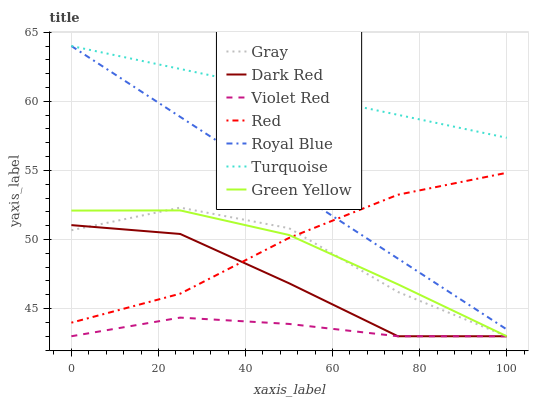Does Violet Red have the minimum area under the curve?
Answer yes or no. Yes. Does Turquoise have the maximum area under the curve?
Answer yes or no. Yes. Does Dark Red have the minimum area under the curve?
Answer yes or no. No. Does Dark Red have the maximum area under the curve?
Answer yes or no. No. Is Turquoise the smoothest?
Answer yes or no. Yes. Is Gray the roughest?
Answer yes or no. Yes. Is Violet Red the smoothest?
Answer yes or no. No. Is Violet Red the roughest?
Answer yes or no. No. Does Gray have the lowest value?
Answer yes or no. Yes. Does Turquoise have the lowest value?
Answer yes or no. No. Does Royal Blue have the highest value?
Answer yes or no. Yes. Does Dark Red have the highest value?
Answer yes or no. No. Is Dark Red less than Royal Blue?
Answer yes or no. Yes. Is Royal Blue greater than Green Yellow?
Answer yes or no. Yes. Does Violet Red intersect Gray?
Answer yes or no. Yes. Is Violet Red less than Gray?
Answer yes or no. No. Is Violet Red greater than Gray?
Answer yes or no. No. Does Dark Red intersect Royal Blue?
Answer yes or no. No. 